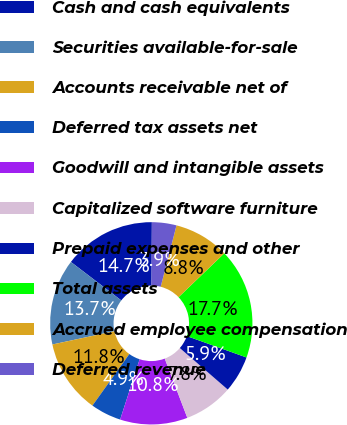Convert chart. <chart><loc_0><loc_0><loc_500><loc_500><pie_chart><fcel>Cash and cash equivalents<fcel>Securities available-for-sale<fcel>Accounts receivable net of<fcel>Deferred tax assets net<fcel>Goodwill and intangible assets<fcel>Capitalized software furniture<fcel>Prepaid expenses and other<fcel>Total assets<fcel>Accrued employee compensation<fcel>Deferred revenue<nl><fcel>14.71%<fcel>13.73%<fcel>11.76%<fcel>4.9%<fcel>10.78%<fcel>7.84%<fcel>5.88%<fcel>17.65%<fcel>8.82%<fcel>3.92%<nl></chart> 